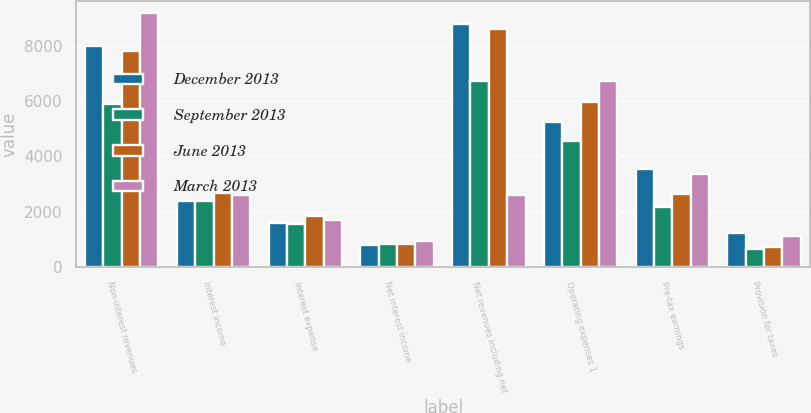Convert chart. <chart><loc_0><loc_0><loc_500><loc_500><stacked_bar_chart><ecel><fcel>Non-interest revenues<fcel>Interest income<fcel>Interest expense<fcel>Net interest income<fcel>Net revenues including net<fcel>Operating expenses 1<fcel>Pre-tax earnings<fcel>Provision for taxes<nl><fcel>December 2013<fcel>7981<fcel>2391<fcel>1590<fcel>801<fcel>8782<fcel>5230<fcel>3552<fcel>1220<nl><fcel>September 2013<fcel>5882<fcel>2398<fcel>1558<fcel>840<fcel>6722<fcel>4555<fcel>2167<fcel>650<nl><fcel>June 2013<fcel>7786<fcel>2663<fcel>1837<fcel>826<fcel>8612<fcel>5967<fcel>2645<fcel>714<nl><fcel>March 2013<fcel>9165<fcel>2608<fcel>1683<fcel>925<fcel>2608<fcel>6717<fcel>3373<fcel>1113<nl></chart> 